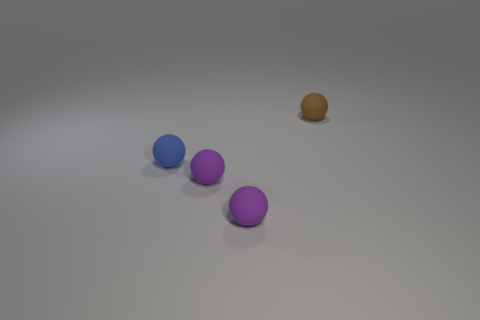There is a tiny brown rubber sphere that is behind the small blue ball; what number of spheres are on the left side of it?
Your answer should be compact. 3. What number of tiny purple things have the same shape as the small blue matte thing?
Ensure brevity in your answer.  2. There is a object that is behind the blue ball; what material is it?
Provide a succinct answer. Rubber. There is a tiny thing behind the blue thing; is its shape the same as the blue thing?
Keep it short and to the point. Yes. Is there another brown rubber object that has the same size as the brown object?
Offer a terse response. No. Is the number of purple matte objects in front of the brown ball less than the number of rubber objects?
Your answer should be compact. Yes. Is the brown rubber thing the same shape as the tiny blue object?
Ensure brevity in your answer.  Yes. Is the number of large purple spheres less than the number of tiny purple things?
Give a very brief answer. Yes. How many large things are either brown rubber objects or cyan matte objects?
Give a very brief answer. 0. How many rubber objects are on the right side of the tiny blue matte ball and in front of the tiny brown ball?
Give a very brief answer. 2. 